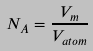<formula> <loc_0><loc_0><loc_500><loc_500>N _ { A } = \frac { V _ { m } } { V _ { a t o m } }</formula> 